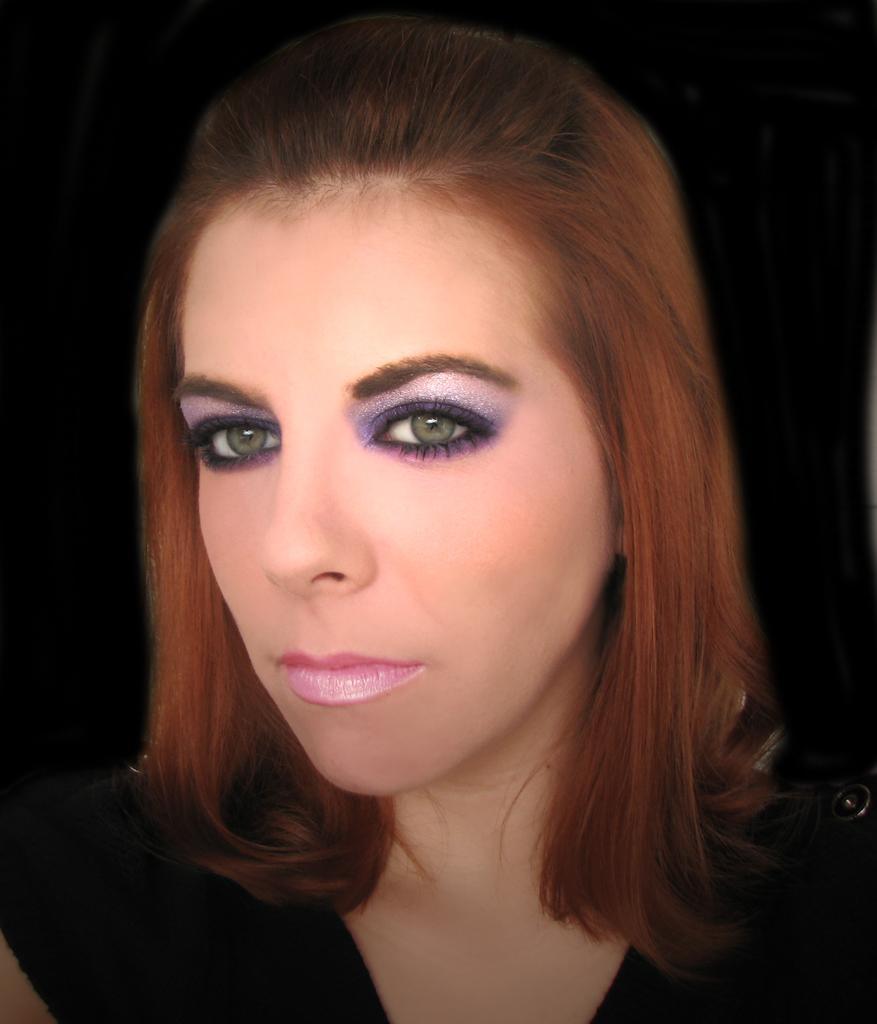Could you give a brief overview of what you see in this image? In this picture I can see a woman is wearing a black dress. 